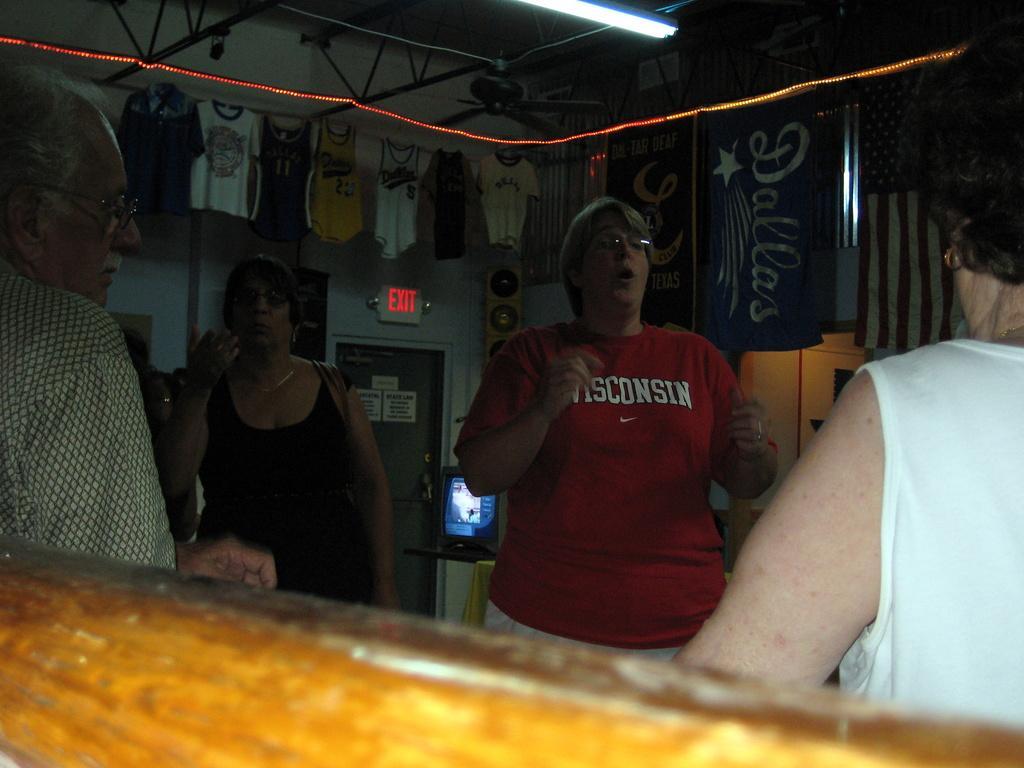Can you describe this image briefly? In this picture we can see four persons are standing, on the right side there are flags, in the background we can see clothes, we can also see a speaker, a television, an exit board and a door in the background, there is a light at the top of the picture. 